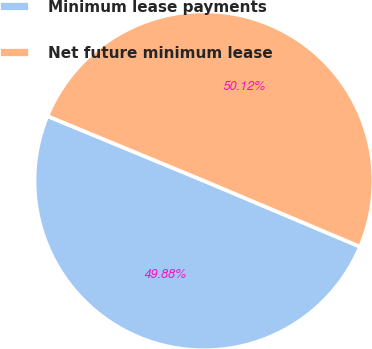<chart> <loc_0><loc_0><loc_500><loc_500><pie_chart><fcel>Minimum lease payments<fcel>Net future minimum lease<nl><fcel>49.88%<fcel>50.12%<nl></chart> 